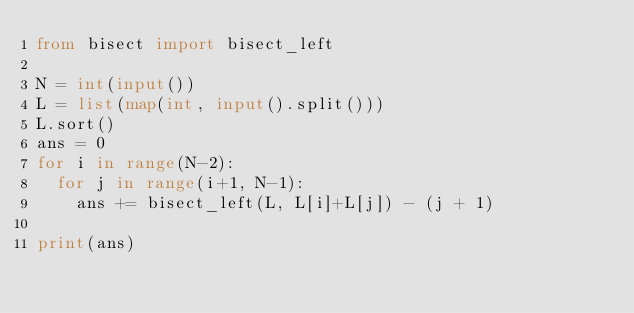Convert code to text. <code><loc_0><loc_0><loc_500><loc_500><_Python_>from bisect import bisect_left

N = int(input())
L = list(map(int, input().split()))
L.sort()
ans = 0
for i in range(N-2):
  for j in range(i+1, N-1):
    ans += bisect_left(L, L[i]+L[j]) - (j + 1)

print(ans)</code> 